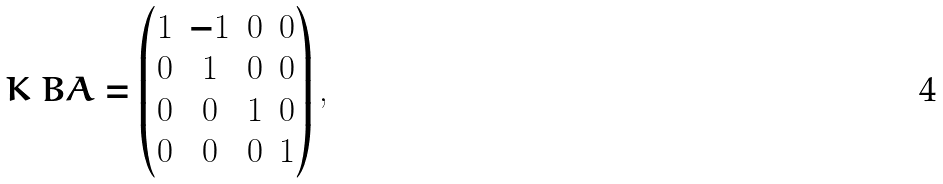Convert formula to latex. <formula><loc_0><loc_0><loc_500><loc_500>K _ { \ } B A = \begin{pmatrix} 1 & - 1 & 0 & 0 \\ 0 & 1 & 0 & 0 \\ 0 & 0 & 1 & 0 \\ 0 & 0 & 0 & 1 \end{pmatrix} ,</formula> 